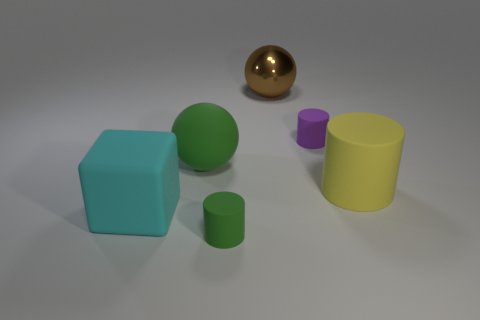There is a block that is the same material as the large yellow object; what color is it? cyan 